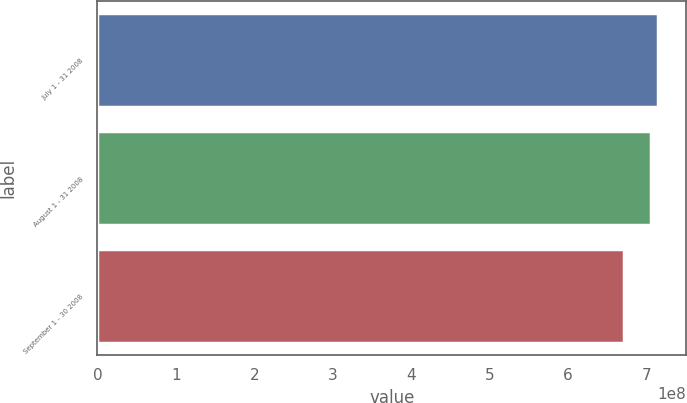Convert chart to OTSL. <chart><loc_0><loc_0><loc_500><loc_500><bar_chart><fcel>July 1 - 31 2008<fcel>August 1 - 31 2008<fcel>September 1 - 30 2008<nl><fcel>7.1465e+08<fcel>7.05412e+08<fcel>6.71188e+08<nl></chart> 